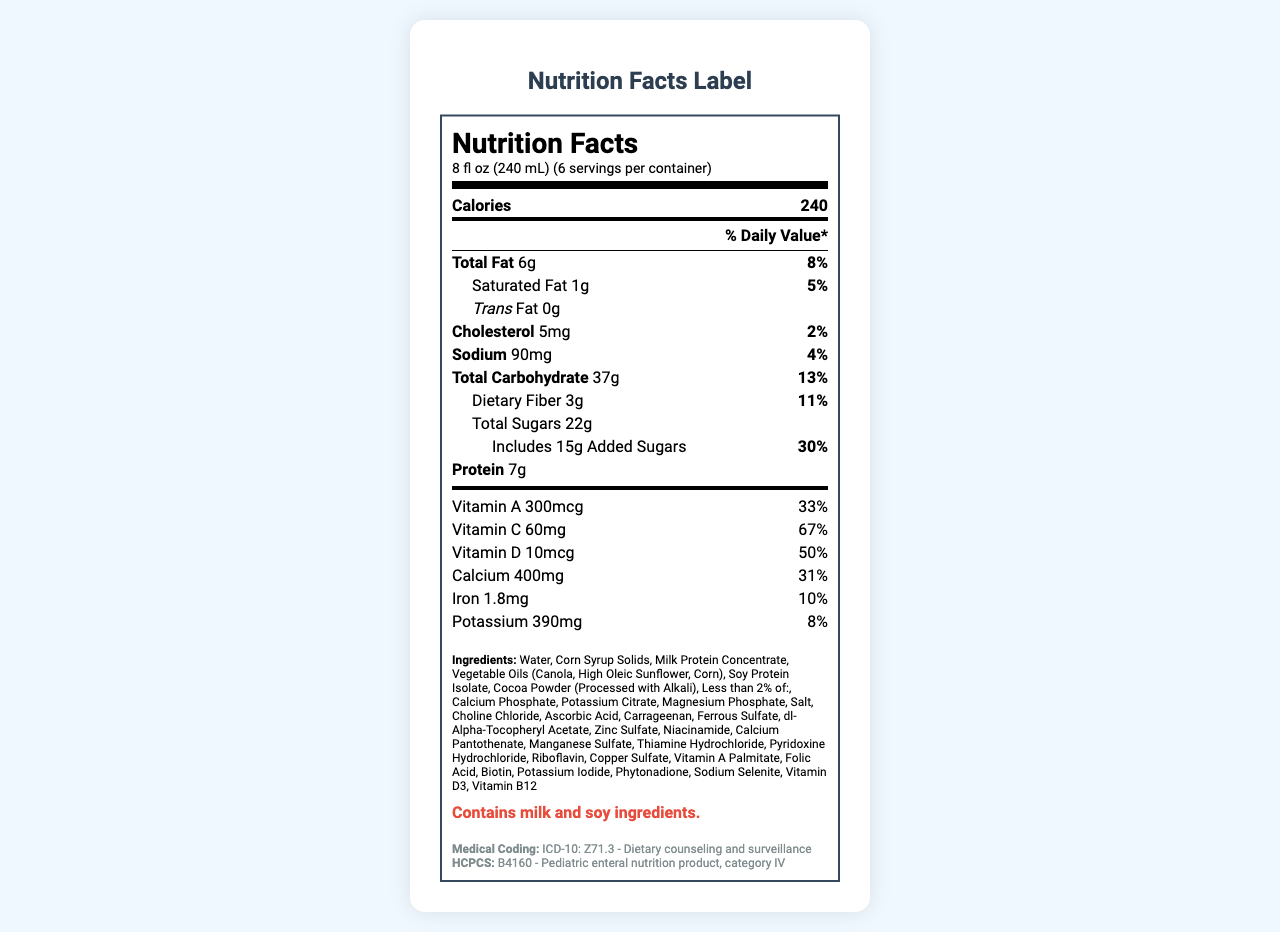What is the serving size for KiddiBoost Plus? The serving size is directly mentioned in the serving information section located at the top of the nutrition facts label.
Answer: 8 fl oz (240 mL) How many calories are in one serving of KiddiBoost Plus? The number of calories per serving is mentioned prominently in the nutrition label just under the serving size section.
Answer: 240 calories How much protein is in one serving of KiddiBoost Plus? The protein content per serving is stated in the nutrition label section.
Answer: 7g What is the daily value percentage for Vitamin C in one serving? The daily value percentage for Vitamin C can be found in the vitamins section of the nutrition facts label.
Answer: 67% List the main fat-related nutrients and their daily value percentages. The daily value percentages for Total Fat and Saturated Fat are given in the nutrition facts under their respective labels.
Answer: Total Fat: 8%, Saturated Fat: 5% How much added sugar does one serving of KiddiBoost Plus contain? The amount of added sugar is listed under the "Total Sugars" section in the nutrition facts.
Answer: 15g Which of the following vitamins have a daily value percentage of 25% in one serving of KiddiBoost Plus? A. Thiamin B. Folate C. Riboflavin Thiamin and Folate each have a daily value percentage of 25% as per the nutrition facts label.
Answer: A and B How many servings does one container of KiddiBoost Plus hold? A. 4 B. 6 C. 8 The servings per container is mentioned at the top of the nutrition facts label as 6.
Answer: B Does KiddiBoost Plus contain Vitamin D3? Yes or No The ingredient list includes "Vitamin D3," confirming its presence.
Answer: Yes Summarize the main idea of the document. The document provides a comprehensive overview of the nutritional content, ingredients, and medical coding information for KiddiBoost Plus, aimed at ensuring accurate billing for health professionals.
Answer: The document provides detailed nutrition information for KiddiBoost Plus, a pediatric nutritional supplement drink with added vitamins and minerals. It includes serving size, calorie count, and the amounts of various fats, proteins, vitamins, and minerals. The document also covers allergen information and medical coding notes for billing purposes. What is the unique ICD-10 code associated with KiddiBoost Plus? The ICD-10 code for dietary counseling and surveillance, which applies to KiddiBoost Plus, is listed in the medical coding notes section of the document.
Answer: Z71.3 Is there enough information to determine if KiddiBoost Plus is gluten-free? There is no information provided about the gluten content in the document.
Answer: Cannot be determined What is the amount of calcium in one serving of KiddiBoost Plus? The calcium amount per serving is listed in the vitamins and minerals section of the nutrition facts.
Answer: 400mg What percentage of the daily value for Selenium does one serving of KiddiBoost Plus provide? A. 25% B. 36% C. 40% Selenium provides 36% of the daily value per serving as outlined in the nutrition facts.
Answer: B Does the document mention any allergens contained in KiddiBoost Plus? The allergen statement mentions that KiddiBoost Plus contains milk and soy ingredients.
Answer: Yes What is the recommended use for KiddiBoost Plus according to the medical coding notes? The medical coding notes indicate that KiddiBoost Plus may be prescribed for nutritional supplementation, coded under dietary counseling and surveillance.
Answer: Nutritional supplementation 